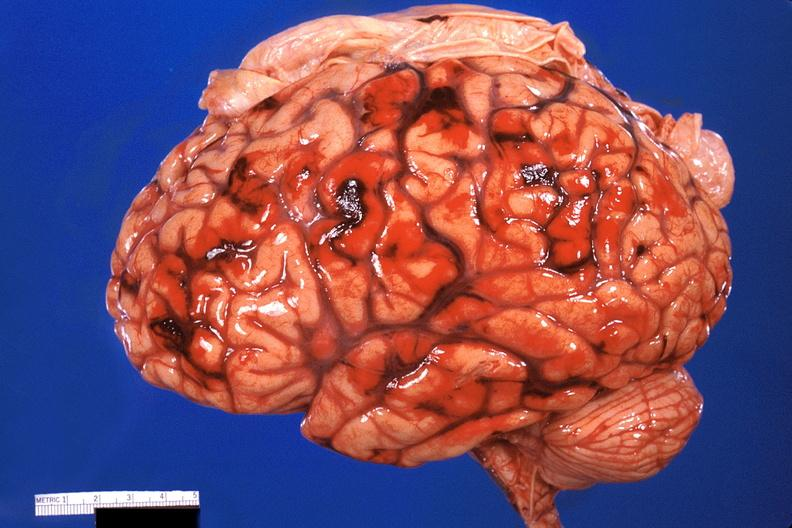s nervous present?
Answer the question using a single word or phrase. Yes 